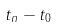<formula> <loc_0><loc_0><loc_500><loc_500>t _ { n } - t _ { 0 }</formula> 